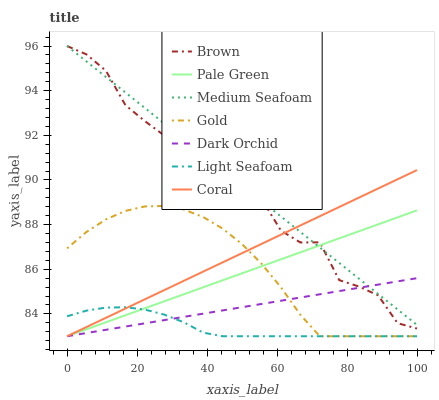Does Light Seafoam have the minimum area under the curve?
Answer yes or no. Yes. Does Medium Seafoam have the maximum area under the curve?
Answer yes or no. Yes. Does Gold have the minimum area under the curve?
Answer yes or no. No. Does Gold have the maximum area under the curve?
Answer yes or no. No. Is Pale Green the smoothest?
Answer yes or no. Yes. Is Brown the roughest?
Answer yes or no. Yes. Is Gold the smoothest?
Answer yes or no. No. Is Gold the roughest?
Answer yes or no. No. Does Gold have the lowest value?
Answer yes or no. Yes. Does Medium Seafoam have the lowest value?
Answer yes or no. No. Does Medium Seafoam have the highest value?
Answer yes or no. Yes. Does Gold have the highest value?
Answer yes or no. No. Is Gold less than Brown?
Answer yes or no. Yes. Is Brown greater than Light Seafoam?
Answer yes or no. Yes. Does Coral intersect Gold?
Answer yes or no. Yes. Is Coral less than Gold?
Answer yes or no. No. Is Coral greater than Gold?
Answer yes or no. No. Does Gold intersect Brown?
Answer yes or no. No. 